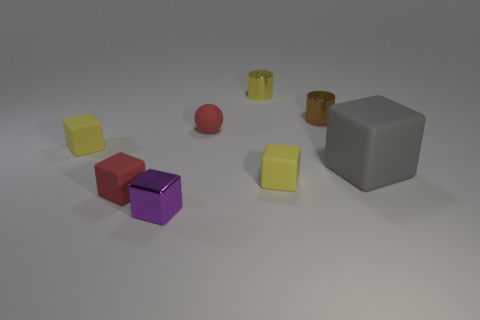Can you describe the shapes and colors of the objects in the image? Certainly! The image features a collection of geometric shapes consisting of cubes, cylinders, and a sphere. There are two yellow cubes, one red cube, and one purple cube. Additionally, there are two cylinders, one yellow and one brown. There's also a singular red sphere and a large grey cube in the scene. The colors are quite distinct and give the scene a playful, almost toy-like appearance. 